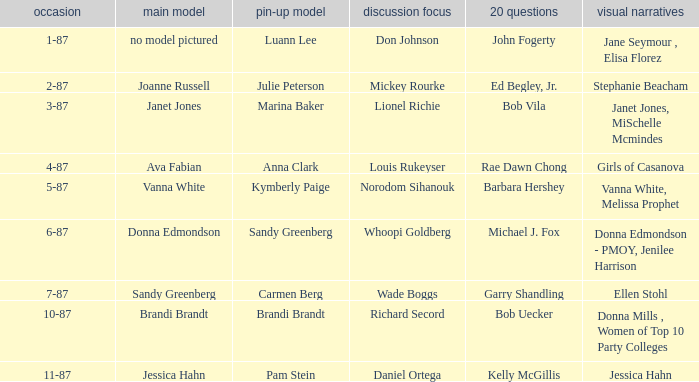Who was the on the cover when Bob Vila did the 20 Questions? Janet Jones. Could you help me parse every detail presented in this table? {'header': ['occasion', 'main model', 'pin-up model', 'discussion focus', '20 questions', 'visual narratives'], 'rows': [['1-87', 'no model pictured', 'Luann Lee', 'Don Johnson', 'John Fogerty', 'Jane Seymour , Elisa Florez'], ['2-87', 'Joanne Russell', 'Julie Peterson', 'Mickey Rourke', 'Ed Begley, Jr.', 'Stephanie Beacham'], ['3-87', 'Janet Jones', 'Marina Baker', 'Lionel Richie', 'Bob Vila', 'Janet Jones, MiSchelle Mcmindes'], ['4-87', 'Ava Fabian', 'Anna Clark', 'Louis Rukeyser', 'Rae Dawn Chong', 'Girls of Casanova'], ['5-87', 'Vanna White', 'Kymberly Paige', 'Norodom Sihanouk', 'Barbara Hershey', 'Vanna White, Melissa Prophet'], ['6-87', 'Donna Edmondson', 'Sandy Greenberg', 'Whoopi Goldberg', 'Michael J. Fox', 'Donna Edmondson - PMOY, Jenilee Harrison'], ['7-87', 'Sandy Greenberg', 'Carmen Berg', 'Wade Boggs', 'Garry Shandling', 'Ellen Stohl'], ['10-87', 'Brandi Brandt', 'Brandi Brandt', 'Richard Secord', 'Bob Uecker', 'Donna Mills , Women of Top 10 Party Colleges'], ['11-87', 'Jessica Hahn', 'Pam Stein', 'Daniel Ortega', 'Kelly McGillis', 'Jessica Hahn']]} 